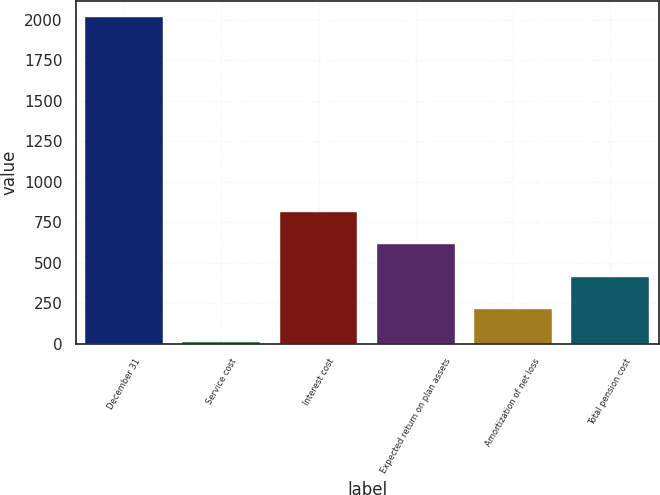Convert chart to OTSL. <chart><loc_0><loc_0><loc_500><loc_500><bar_chart><fcel>December 31<fcel>Service cost<fcel>Interest cost<fcel>Expected return on plan assets<fcel>Amortization of net loss<fcel>Total pension cost<nl><fcel>2016<fcel>13<fcel>814.2<fcel>613.9<fcel>213.3<fcel>413.6<nl></chart> 